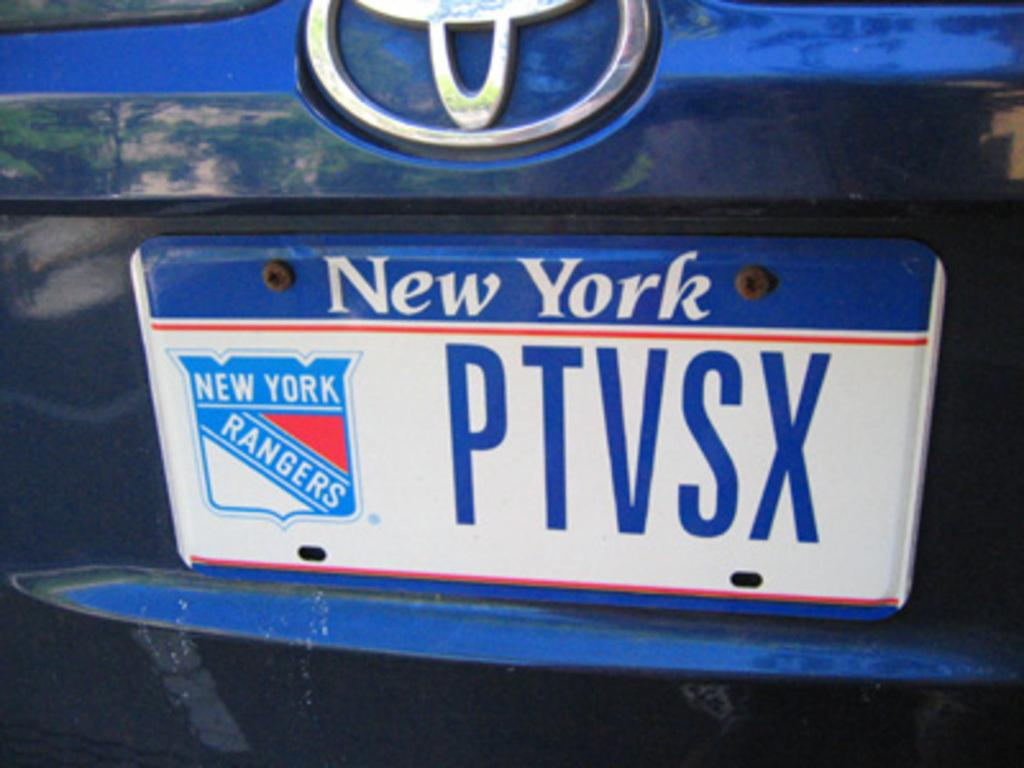<image>
Summarize the visual content of the image. A New York license plate has the text PTVSX on it. 